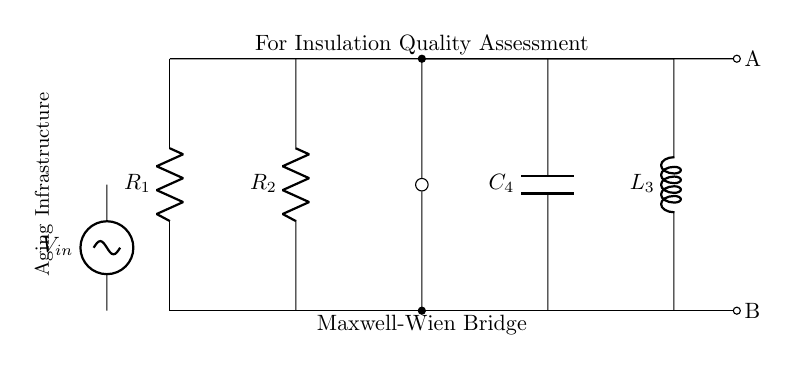What are the components of the circuit? The components include resistors, a capacitor, an inductor, and a voltage source. These can be identified in the diagram: R1 and R2 as resistors, C4 as the capacitor, L3 as the inductor, and the sinusoidal voltage source on the left.
Answer: resistors, capacitor, inductor, voltage source What is the function of the Maxwell-Wien bridge? The Maxwell-Wien bridge is used for measuring the quality of electrical insulation, particularly in aging infrastructure. It compares known and unknown impedance to assess dielectric strength and insulation performance.
Answer: insulation quality assessment Which component is connected to the input voltage? The voltage source labeled as Vin is connected to the circuit, providing the necessary input to evaluate the bridge configuration. It can be found at the left side of the diagram.
Answer: voltage source How many resistors are in the circuit? There are two resistors in the circuit as indicated by R1 and R2. Each is positioned vertically on the left side of the diagram.
Answer: two What is the purpose of the capacitor in the bridge? The capacitor C4 is part of the bridge circuit designed to balance the impedance. It plays a crucial role in the frequency response and helps assess the insulation quality based on dielectric properties.
Answer: balance impedance What will happen if one of the resistors fails? If one of the resistors, such as R1 or R2, fails, it will disrupt the balance of the bridge, leading to an inaccurate measurement. This imbalance can significantly affect the electrical parameters being analyzed, potentially indicating poor insulation.
Answer: inaccurate measurement 